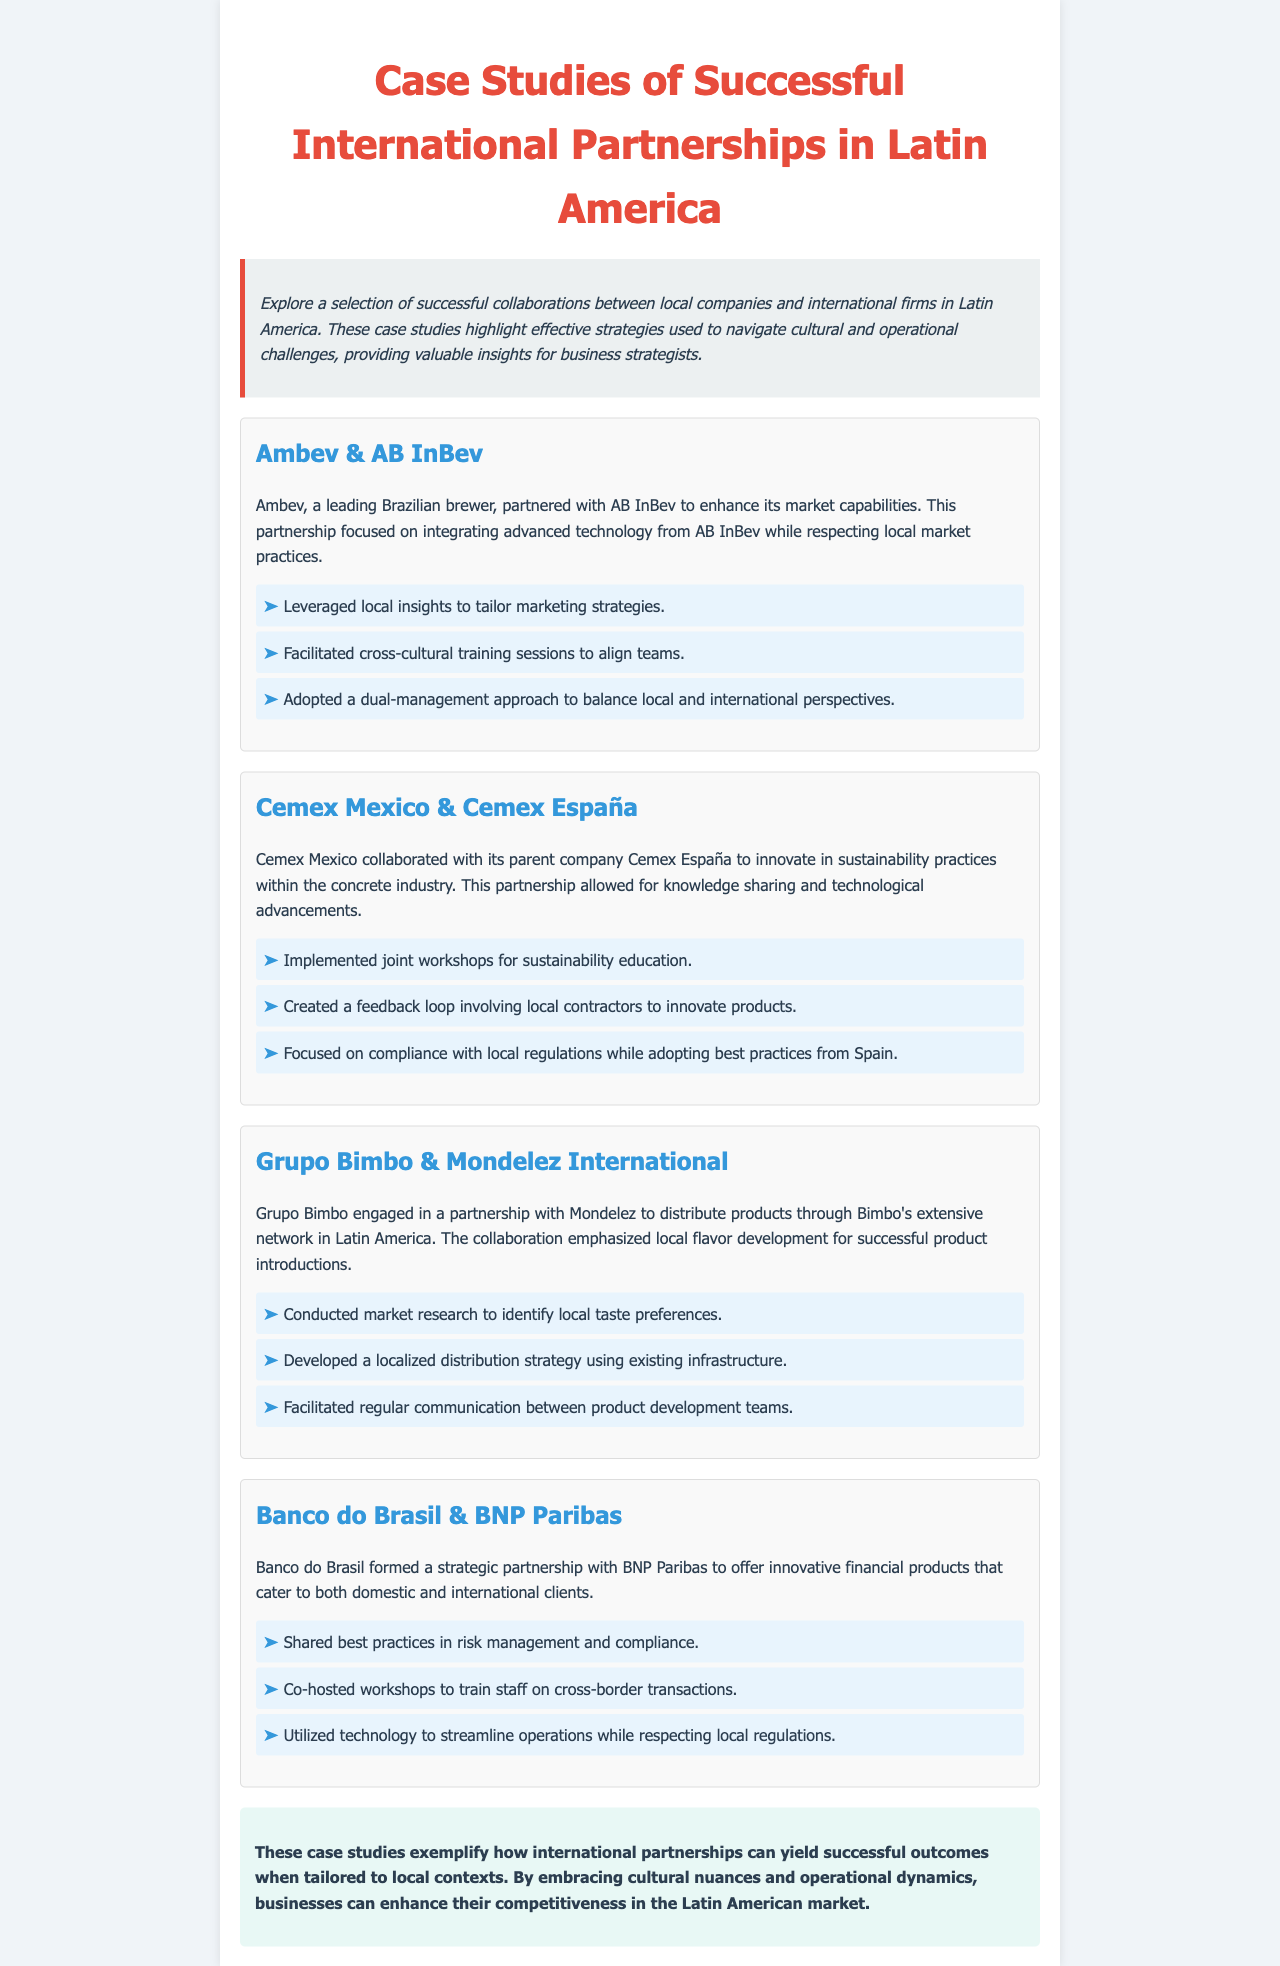What is the title of the newsletter? The title is prominently displayed at the top of the document, summarizing the topic of international partnerships.
Answer: Case Studies of Successful International Partnerships in Latin America Which Brazilian company partnered with AB InBev? The partnership detailed in the case study specifically names Ambev as the local company collaborating with AB InBev.
Answer: Ambev What was the focus of Cemex Mexico's partnership with Cemex España? The document states the partnership's emphasis on sustainability practices within the concrete industry.
Answer: Sustainability practices What local aspect did Grupo Bimbo emphasize in their partnership with Mondelez? The case study mentions the importance of local flavor development for product introductions.
Answer: Local flavor development How many strategies were listed in the Banco do Brasil and BNP Paribas case study? The number of strategies provided in the case study can be counted from the list section.
Answer: Three 